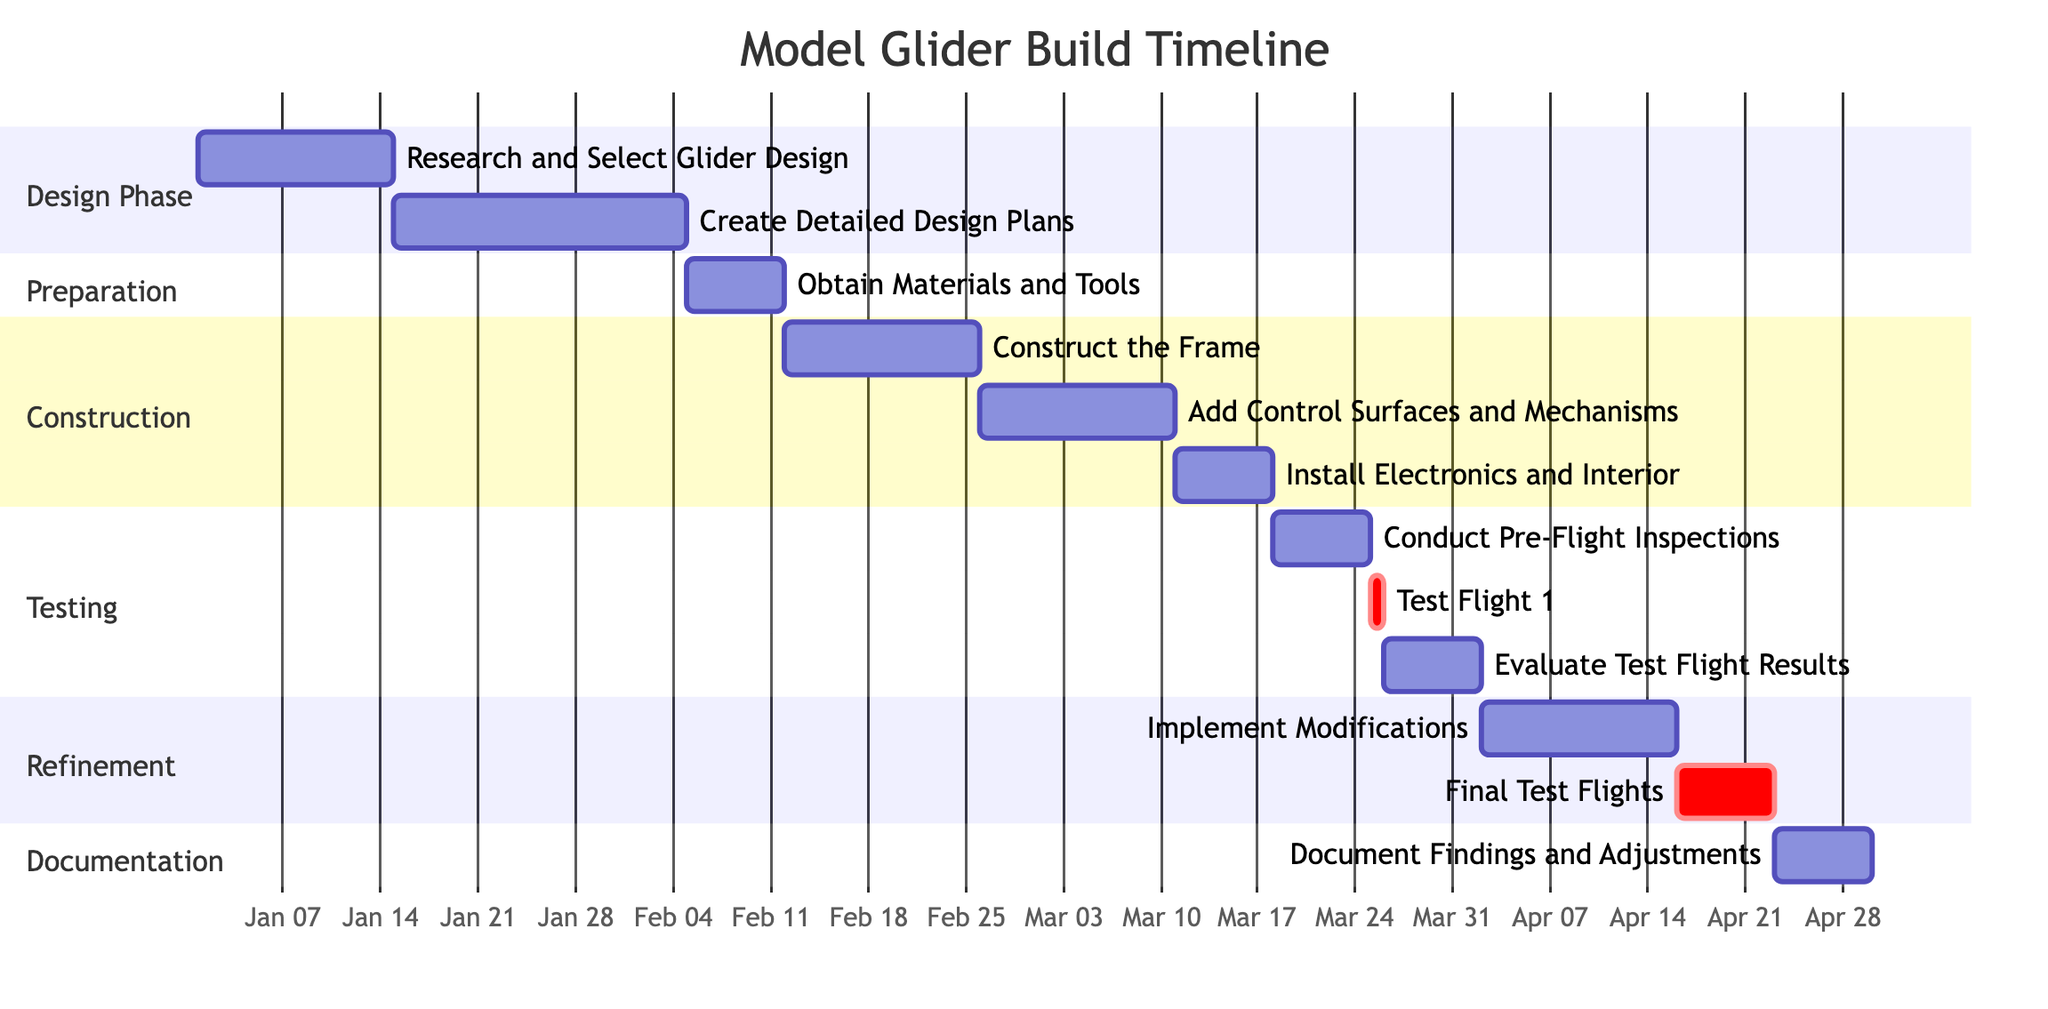What is the duration of the "Create Detailed Design Plans" task? The task "Create Detailed Design Plans" has a duration of 3 weeks, as indicated in the diagram's detailed information for that specific task.
Answer: 3 weeks When does the "Evaluate Test Flight Results" task start? The "Evaluate Test Flight Results" task starts on March 26, 2024, which is shown clearly in the timeline for that specific task.
Answer: March 26, 2024 How many tasks are in the "Construction" phase? There are three tasks in the "Construction" phase: "Construct the Frame," "Add Control Surfaces and Mechanisms," and "Install Electronics and Interior," which can be counted directly from the diagram.
Answer: 3 Which task immediately follows "Install Electronics and Interior"? The task that immediately follows "Install Electronics and Interior" is "Conduct Pre-Flight Inspections," as it is placed directly after it in the timeline sequence.
Answer: Conduct Pre-Flight Inspections What is the end date of the "Final Test Flights" task? The "Final Test Flights" task ends on April 23, 2024, which can be deduced from the start date of April 16, 2024, and its duration of 1 week.
Answer: April 23, 2024 Which task has the same start date as the "Evaluate Test Flight Results"? The task "Test Flight 1" has the same start date as "Evaluate Test Flight Results," occurring on March 26, 2024, and can be verified by examining the corresponding timeline spots for both tasks.
Answer: Test Flight 1 How long before the "Document Findings and Adjustments" does the "Final Test Flights" start? The "Final Test Flights" start on April 16, 2024, while "Document Findings and Adjustments" begins on April 23, 2024, thus indicating there are 1 week between them.
Answer: 1 week Which phase includes the task "Obtain Materials and Tools"? The task "Obtain Materials and Tools" is included in the "Preparation" phase, as defined in the sections of the Gantt chart where this task is categorized.
Answer: Preparation 